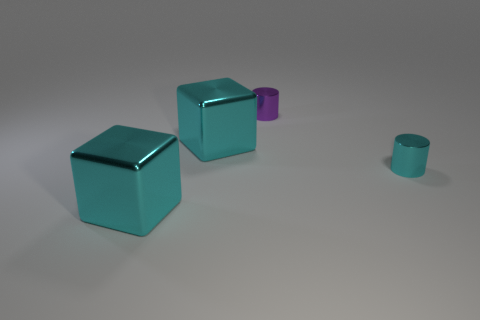Add 2 metallic objects. How many objects exist? 6 Subtract all tiny purple cylinders. Subtract all tiny purple shiny cylinders. How many objects are left? 2 Add 1 tiny cyan cylinders. How many tiny cyan cylinders are left? 2 Add 4 cyan metal cylinders. How many cyan metal cylinders exist? 5 Subtract 0 gray spheres. How many objects are left? 4 